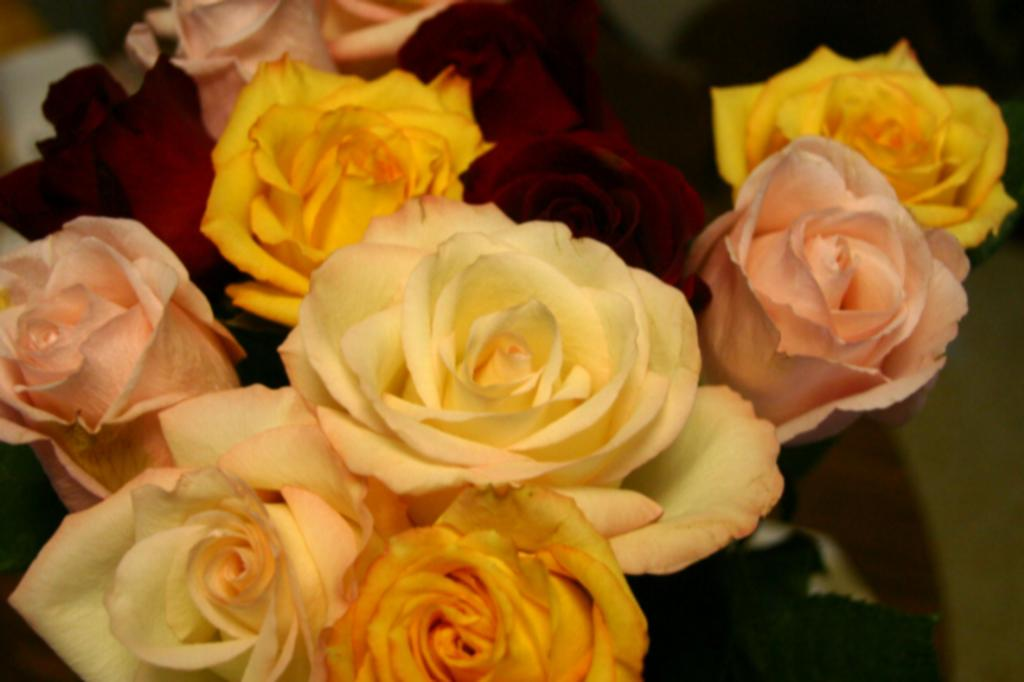What types of flowers are in the image? There are different roses in the image. What colors can be seen in the roses? The roses are in yellow, red, pink, and white colors. How many pizzas are present in the image? There are no pizzas present in the image; it features different roses in various colors. Can you describe the texture of the feather in the image? There is no feather present in the image; it only contains different roses in yellow, red, pink, and white colors. 